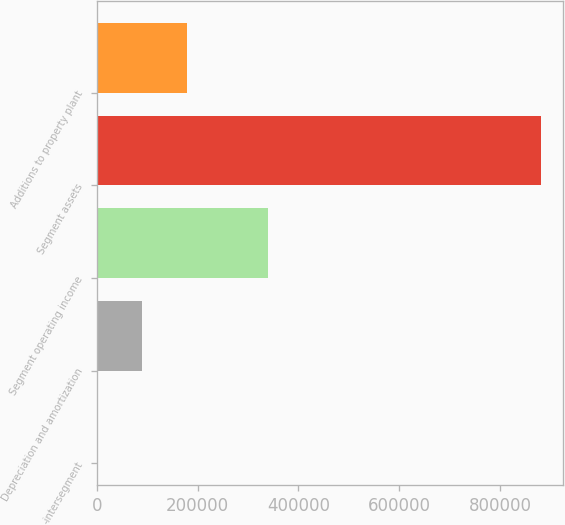Convert chart to OTSL. <chart><loc_0><loc_0><loc_500><loc_500><bar_chart><fcel>-intersegment<fcel>Depreciation and amortization<fcel>Segment operating income<fcel>Segment assets<fcel>Additions to property plant<nl><fcel>2755<fcel>90535<fcel>339458<fcel>880555<fcel>178315<nl></chart> 